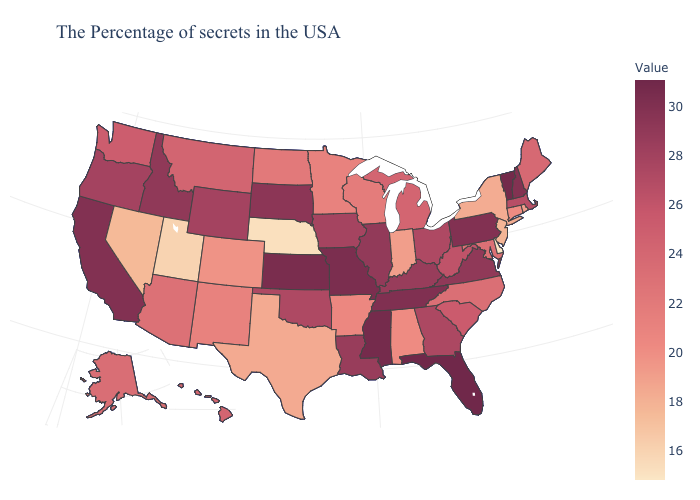Does New Jersey have the lowest value in the Northeast?
Short answer required. Yes. Among the states that border Wyoming , which have the highest value?
Answer briefly. South Dakota. Among the states that border Pennsylvania , which have the highest value?
Be succinct. Ohio. Which states have the lowest value in the West?
Keep it brief. Utah. Among the states that border Tennessee , does Alabama have the lowest value?
Short answer required. Yes. 